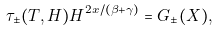<formula> <loc_0><loc_0><loc_500><loc_500>\tau _ { \pm } ( T , H ) H ^ { 2 x / ( \beta + \gamma ) } = G _ { \pm } ( X ) ,</formula> 